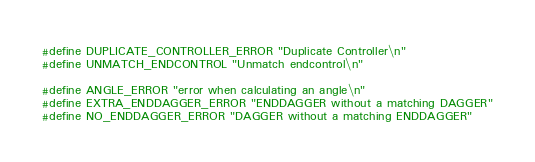Convert code to text. <code><loc_0><loc_0><loc_500><loc_500><_C_>
#define DUPLICATE_CONTROLLER_ERROR "Duplicate Controller\n"
#define UNMATCH_ENDCONTROL "Unmatch endcontrol\n"

#define ANGLE_ERROR "error when calculating an angle\n"
#define EXTRA_ENDDAGGER_ERROR "ENDDAGGER without a matching DAGGER"
#define NO_ENDDAGGER_ERROR "DAGGER without a matching ENDDAGGER"
</code> 